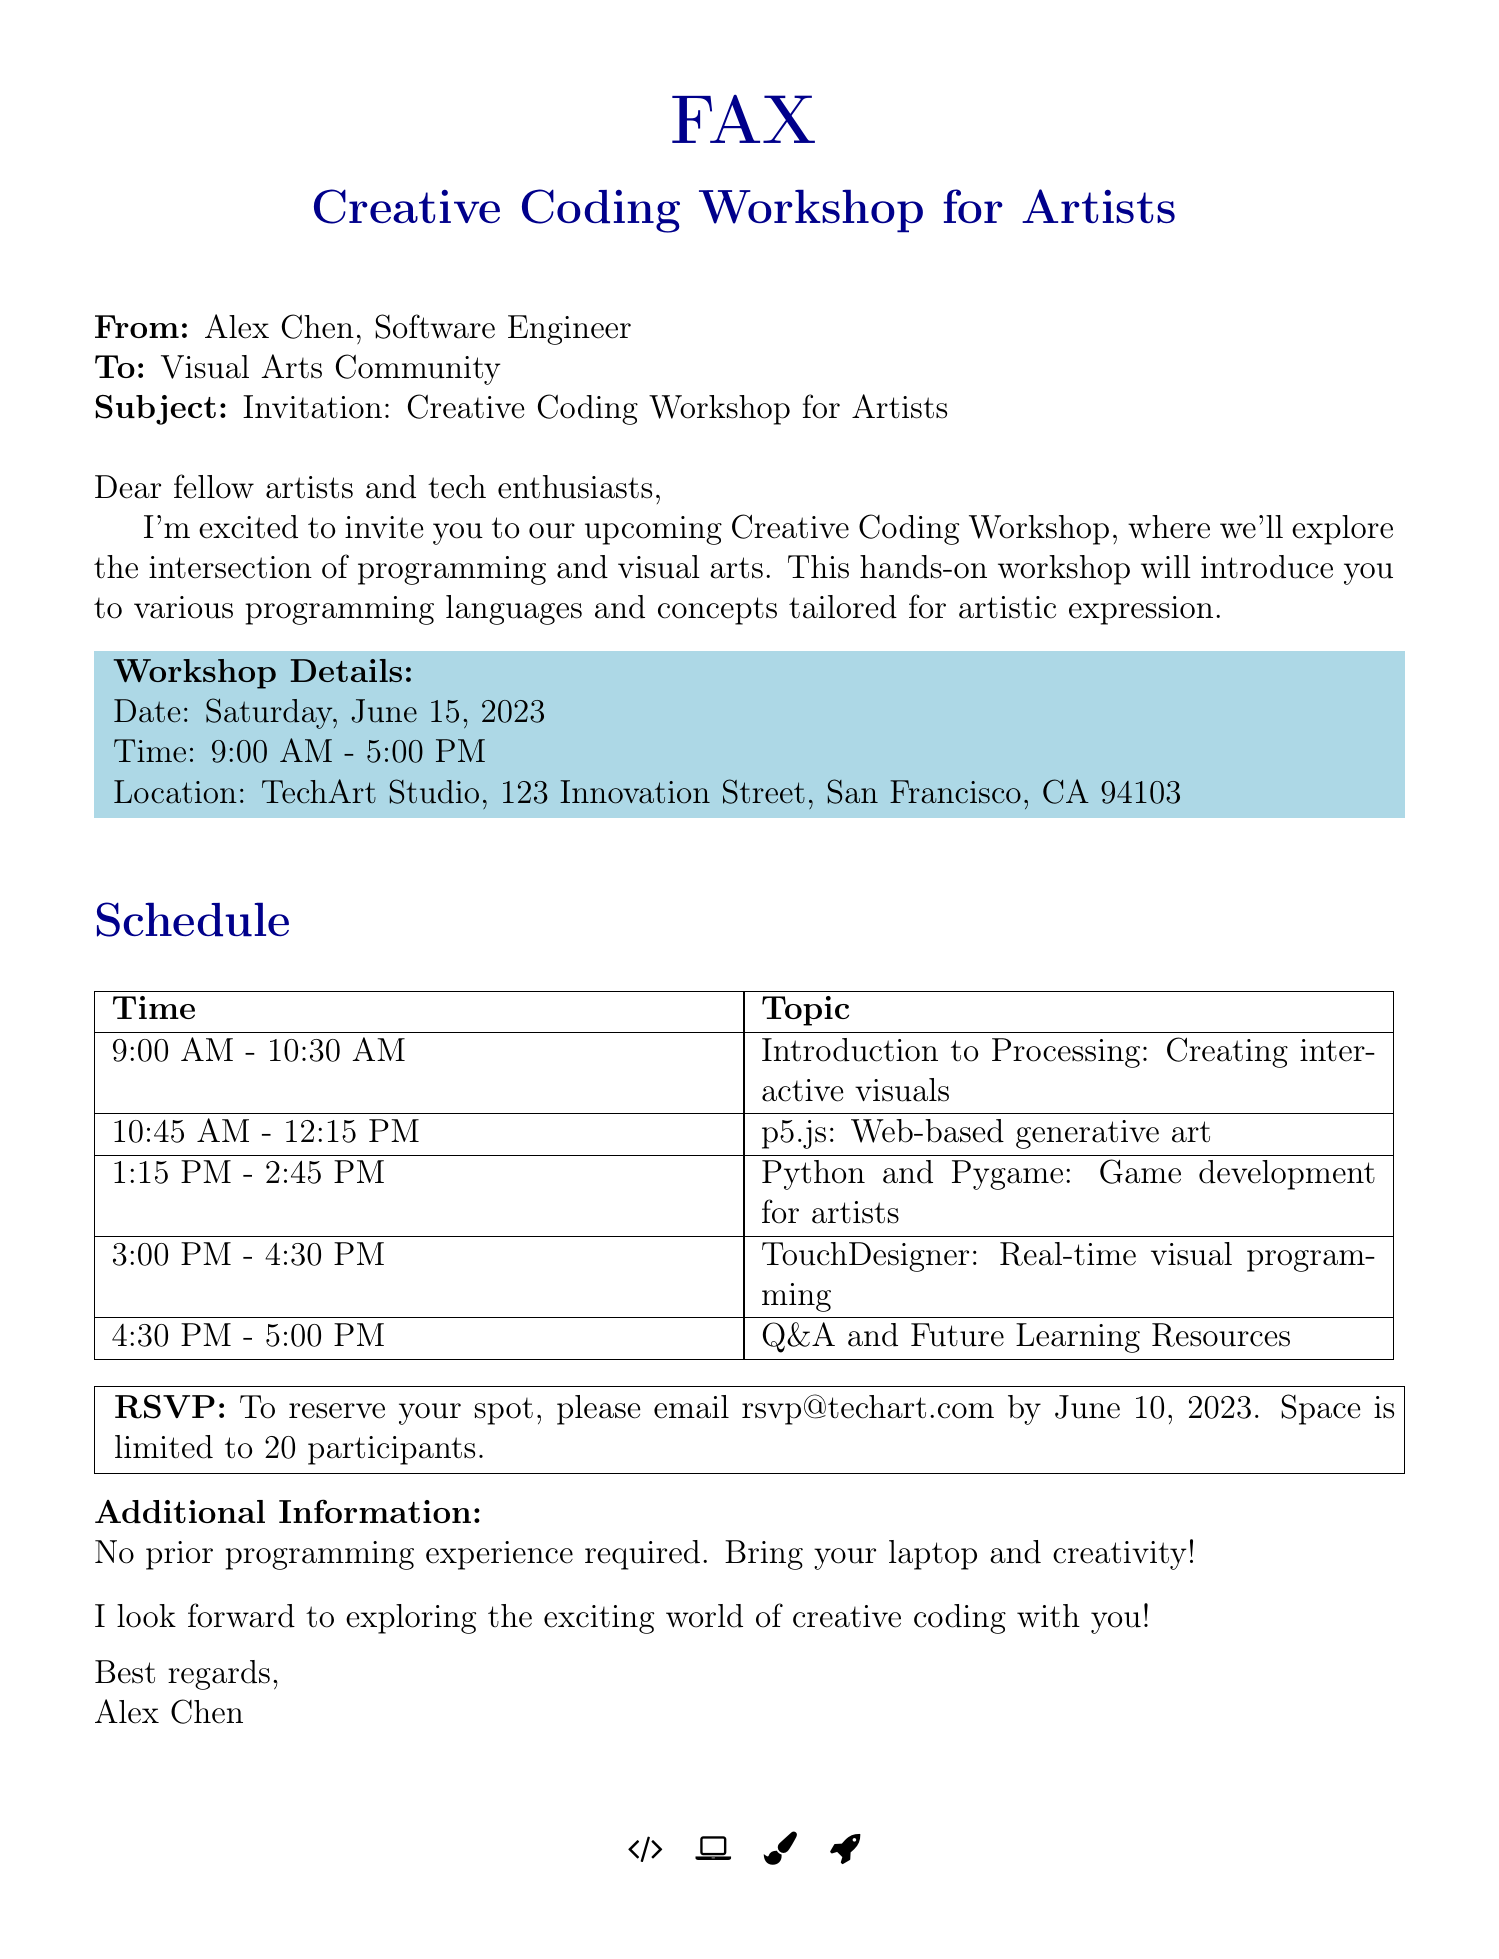What is the workshop date? The date of the workshop is mentioned in the document.
Answer: Saturday, June 15, 2023 What is the location of the workshop? The document states the physical location where the workshop will be held.
Answer: TechArt Studio, 123 Innovation Street, San Francisco, CA 94103 How many participants can attend the workshop? The document specifies the limit on the number of participants.
Answer: 20 What is the topic covered at 1:15 PM? The schedule outlines the specific topics covered at different times during the workshop.
Answer: Python and Pygame: Game development for artists Who is the sender of the fax? The document indicates the individual who is sending out the invitation.
Answer: Alex Chen What is the email for RSVP? The document provides the email to reserve a spot for the workshop.
Answer: rsvp@techart.com What programming language is introduced first? The schedule lists the programming languages in the order they are introduced.
Answer: Processing What time does the Q&A session begin? The schedule outlines the time slots for each topic, including the Q&A session.
Answer: 4:30 PM 